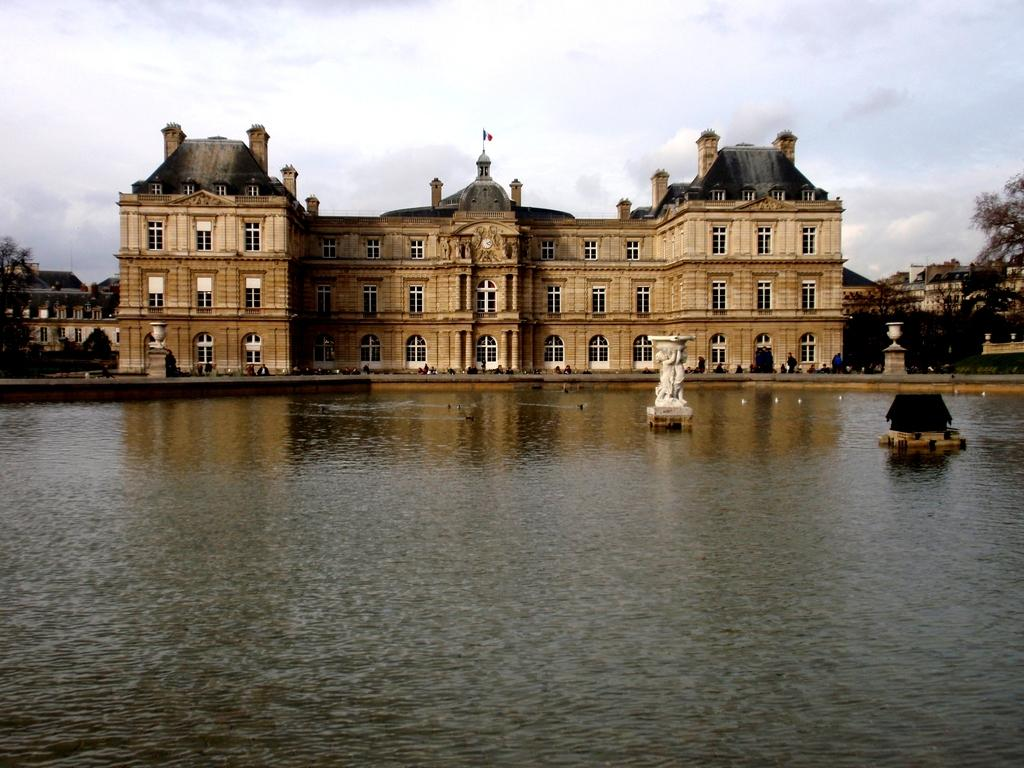What is the main structure in the center of the image? There is a palace in the center of the image. What can be seen at the bottom of the image? There is water at the bottom of the image. What is visible at the top of the image? There are clouds at the top of the image. What type of vegetation is in the background? There are trees in the background of the image. What type of bells can be heard ringing in the image? There are no bells present in the image, and therefore no sound can be heard. Is there a guitar player performing in the image? There is no guitar or guitar player present in the image. 